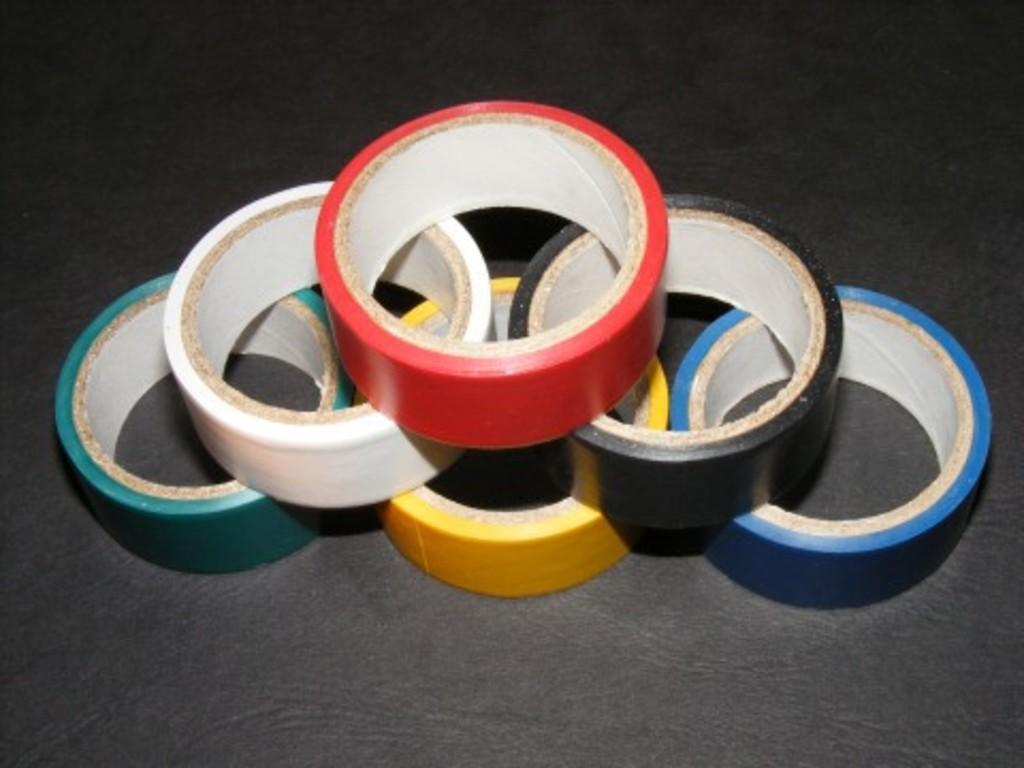Please provide a concise description of this image. This Picture shows different colors of plaster rolls on the black color background. 